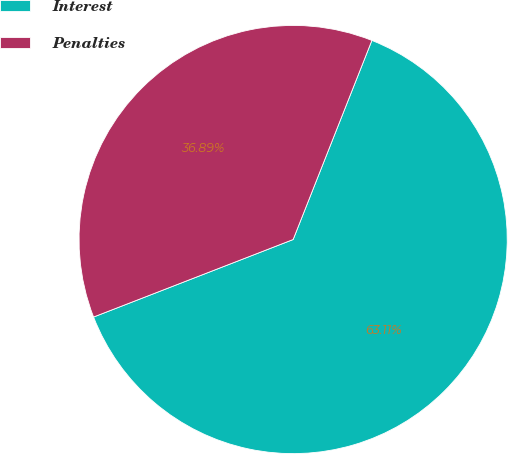Convert chart to OTSL. <chart><loc_0><loc_0><loc_500><loc_500><pie_chart><fcel>Interest<fcel>Penalties<nl><fcel>63.11%<fcel>36.89%<nl></chart> 